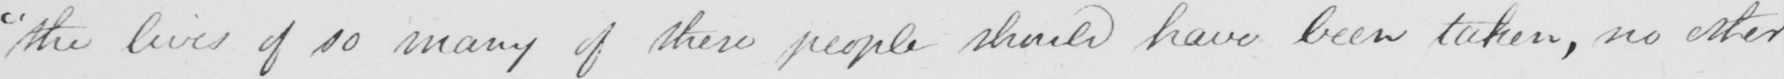Please provide the text content of this handwritten line. " the lives of so many of these people should have been taken , no other 